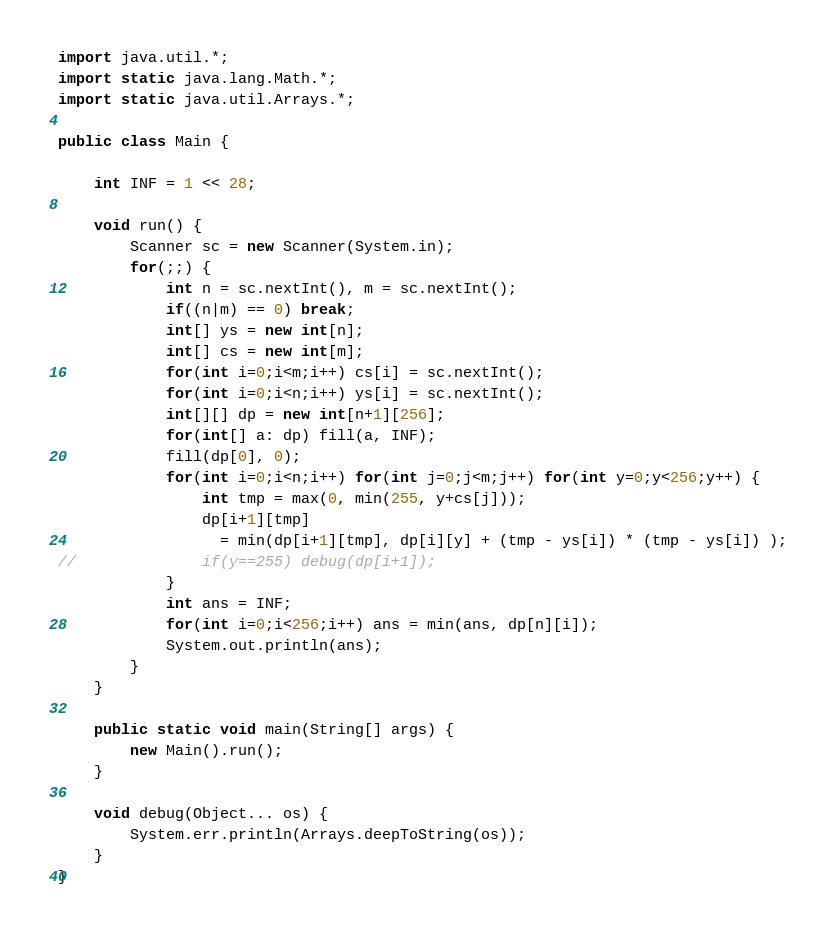<code> <loc_0><loc_0><loc_500><loc_500><_Java_>
import java.util.*;
import static java.lang.Math.*;
import static java.util.Arrays.*;

public class Main {

	int INF = 1 << 28;

	void run() {
		Scanner sc = new Scanner(System.in);
		for(;;) {
			int n = sc.nextInt(), m = sc.nextInt();
			if((n|m) == 0) break;
			int[] ys = new int[n];
			int[] cs = new int[m];
			for(int i=0;i<m;i++) cs[i] = sc.nextInt();
			for(int i=0;i<n;i++) ys[i] = sc.nextInt();
			int[][] dp = new int[n+1][256];
			for(int[] a: dp) fill(a, INF);
			fill(dp[0], 0);
			for(int i=0;i<n;i++) for(int j=0;j<m;j++) for(int y=0;y<256;y++) {
				int tmp = max(0, min(255, y+cs[j]));
				dp[i+1][tmp] 
				  = min(dp[i+1][tmp], dp[i][y] + (tmp - ys[i]) * (tmp - ys[i]) );
//				if(y==255) debug(dp[i+1]);
			}
			int ans = INF;
			for(int i=0;i<256;i++) ans = min(ans, dp[n][i]);
			System.out.println(ans);
		}
	}

	public static void main(String[] args) {
		new Main().run();
	}

	void debug(Object... os) {
		System.err.println(Arrays.deepToString(os));
	}
}</code> 